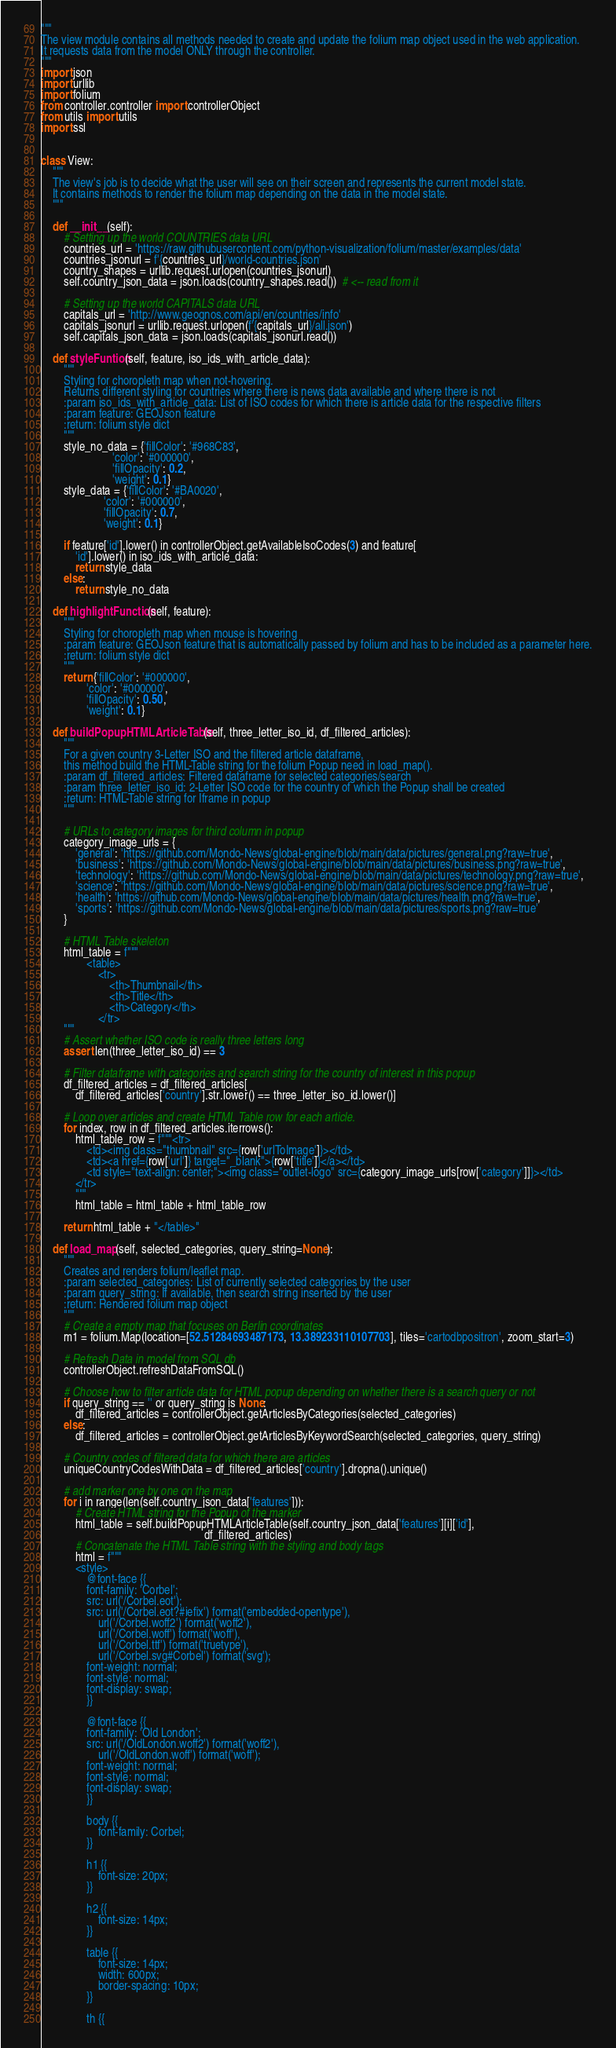<code> <loc_0><loc_0><loc_500><loc_500><_Python_>"""
The view module contains all methods needed to create and update the folium map object used in the web application.
It requests data from the model ONLY through the controller.
"""
import json
import urllib
import folium
from controller.controller import controllerObject
from utils import utils
import ssl


class View:
    """
    The view's job is to decide what the user will see on their screen and represents the current model state.
    It contains methods to render the folium map depending on the data in the model state.
    """

    def __init__(self):
        # Setting up the world COUNTRIES data URL
        countries_url = 'https://raw.githubusercontent.com/python-visualization/folium/master/examples/data'
        countries_jsonurl = f'{countries_url}/world-countries.json'
        country_shapes = urllib.request.urlopen(countries_jsonurl)
        self.country_json_data = json.loads(country_shapes.read())  # <-- read from it

        # Setting up the world CAPITALS data URL
        capitals_url = 'http://www.geognos.com/api/en/countries/info'
        capitals_jsonurl = urllib.request.urlopen(f'{capitals_url}/all.json')
        self.capitals_json_data = json.loads(capitals_jsonurl.read())

    def styleFuntion(self, feature, iso_ids_with_article_data):
        """
        Styling for choropleth map when not-hovering.
        Returns different styling for countries where there is news data available and where there is not
        :param iso_ids_with_article_data: List of ISO codes for which there is article data for the respective filters
        :param feature: GEOJson feature
        :return: folium style dict
        """
        style_no_data = {'fillColor': '#968C83',
                         'color': '#000000',
                         'fillOpacity': 0.2,
                         'weight': 0.1}
        style_data = {'fillColor': '#BA0020',
                      'color': '#000000',
                      'fillOpacity': 0.7,
                      'weight': 0.1}

        if feature['id'].lower() in controllerObject.getAvailableIsoCodes(3) and feature[
            'id'].lower() in iso_ids_with_article_data:
            return style_data
        else:
            return style_no_data

    def highlightFunction(self, feature):
        """
        Styling for choropleth map when mouse is hovering
        :param feature: GEOJson feature that is automatically passed by folium and has to be included as a parameter here.
        :return: folium style dict
        """
        return {'fillColor': '#000000',
                'color': '#000000',
                'fillOpacity': 0.50,
                'weight': 0.1}

    def buildPopupHTMLArticleTable(self, three_letter_iso_id, df_filtered_articles):
        """
        For a given country 3-Letter ISO and the filtered article dataframe,
        this method build the HTML-Table string for the folium Popup need in load_map().
        :param df_filtered_articles: Filtered dataframe for selected categories/search
        :param three_letter_iso_id: 2-Letter ISO code for the country of which the Popup shall be created
        :return: HTML-Table string for Iframe in popup
        """

        # URLs to category images for third column in popup
        category_image_urls = {
            'general': 'https://github.com/Mondo-News/global-engine/blob/main/data/pictures/general.png?raw=true',
            'business': 'https://github.com/Mondo-News/global-engine/blob/main/data/pictures/business.png?raw=true',
            'technology': 'https://github.com/Mondo-News/global-engine/blob/main/data/pictures/technology.png?raw=true',
            'science': 'https://github.com/Mondo-News/global-engine/blob/main/data/pictures/science.png?raw=true',
            'health': 'https://github.com/Mondo-News/global-engine/blob/main/data/pictures/health.png?raw=true',
            'sports': 'https://github.com/Mondo-News/global-engine/blob/main/data/pictures/sports.png?raw=true'
        }

        # HTML Table skeleton
        html_table = f"""
                <table>
                    <tr>
                        <th>Thumbnail</th>
                        <th>Title</th>
                        <th>Category</th>
                    </tr>
        """
        # Assert whether ISO code is really three letters long
        assert len(three_letter_iso_id) == 3

        # Filter dataframe with categories and search string for the country of interest in this popup
        df_filtered_articles = df_filtered_articles[
            df_filtered_articles['country'].str.lower() == three_letter_iso_id.lower()]

        # Loop over articles and create HTML Table row for each article.
        for index, row in df_filtered_articles.iterrows():
            html_table_row = f"""<tr>
                <td><img class="thumbnail" src={row['urlToImage']}></td>
                <td><a href={row['url']} target="_blank">{row['title']}</a></td>
                <td style="text-align: center;"><img class="outlet-logo" src={category_image_urls[row['category']]}></td>
            </tr>
            """
            html_table = html_table + html_table_row

        return html_table + "</table>"

    def load_map(self, selected_categories, query_string=None):
        """
        Creates and renders folium/leaflet map.
        :param selected_categories: List of currently selected categories by the user
        :param query_string: If available, then search string inserted by the user
        :return: Rendered folium map object
        """
        # Create a empty map that focuses on Berlin coordinates
        m1 = folium.Map(location=[52.51284693487173, 13.389233110107703], tiles='cartodbpositron', zoom_start=3)

        # Refresh Data in model from SQL db
        controllerObject.refreshDataFromSQL()

        # Choose how to filter article data for HTML popup depending on whether there is a search query or not
        if query_string == '' or query_string is None:
            df_filtered_articles = controllerObject.getArticlesByCategories(selected_categories)
        else:
            df_filtered_articles = controllerObject.getArticlesByKeywordSearch(selected_categories, query_string)

        # Country codes of filtered data for which there are articles
        uniqueCountryCodesWithData = df_filtered_articles['country'].dropna().unique()

        # add marker one by one on the map
        for i in range(len(self.country_json_data['features'])):
            # Create HTML string for the Popup of the marker
            html_table = self.buildPopupHTMLArticleTable(self.country_json_data['features'][i]['id'],
                                                         df_filtered_articles)
            # Concatenate the HTML Table string with the styling and body tags
            html = f"""
            <style>
                @font-face {{
                font-family: 'Corbel';
                src: url('/Corbel.eot');
                src: url('/Corbel.eot?#iefix') format('embedded-opentype'),
                    url('/Corbel.woff2') format('woff2'),
                    url('/Corbel.woff') format('woff'),
                    url('/Corbel.ttf') format('truetype'),
                    url('/Corbel.svg#Corbel') format('svg');
                font-weight: normal;
                font-style: normal;
                font-display: swap;
                }}
                
                @font-face {{
                font-family: 'Old London';
                src: url('/OldLondon.woff2') format('woff2'),
                    url('/OldLondon.woff') format('woff');
                font-weight: normal;
                font-style: normal;
                font-display: swap;
                }}

                body {{
                    font-family: Corbel;
                }}
            
                h1 {{
                    font-size: 20px;
                }}
            
                h2 {{
                    font-size: 14px;
                }}
            
                table {{
                    font-size: 14px;
                    width: 600px;
                    border-spacing: 10px;
                }}
            
                th {{</code> 